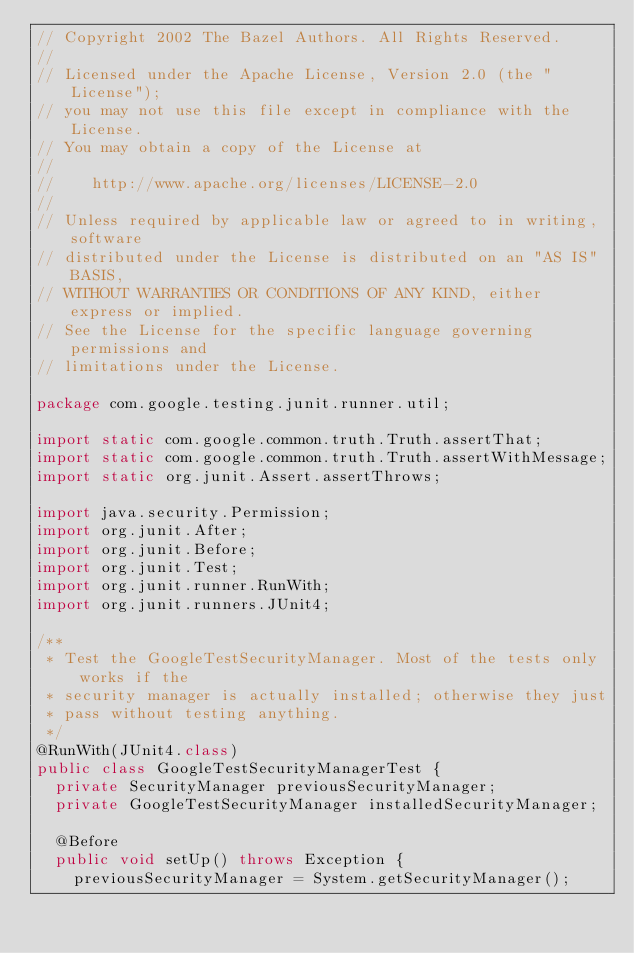Convert code to text. <code><loc_0><loc_0><loc_500><loc_500><_Java_>// Copyright 2002 The Bazel Authors. All Rights Reserved.
//
// Licensed under the Apache License, Version 2.0 (the "License");
// you may not use this file except in compliance with the License.
// You may obtain a copy of the License at
//
//    http://www.apache.org/licenses/LICENSE-2.0
//
// Unless required by applicable law or agreed to in writing, software
// distributed under the License is distributed on an "AS IS" BASIS,
// WITHOUT WARRANTIES OR CONDITIONS OF ANY KIND, either express or implied.
// See the License for the specific language governing permissions and
// limitations under the License.

package com.google.testing.junit.runner.util;

import static com.google.common.truth.Truth.assertThat;
import static com.google.common.truth.Truth.assertWithMessage;
import static org.junit.Assert.assertThrows;

import java.security.Permission;
import org.junit.After;
import org.junit.Before;
import org.junit.Test;
import org.junit.runner.RunWith;
import org.junit.runners.JUnit4;

/**
 * Test the GoogleTestSecurityManager. Most of the tests only works if the
 * security manager is actually installed; otherwise they just
 * pass without testing anything.
 */
@RunWith(JUnit4.class)
public class GoogleTestSecurityManagerTest {
  private SecurityManager previousSecurityManager;
  private GoogleTestSecurityManager installedSecurityManager;

  @Before
  public void setUp() throws Exception {
    previousSecurityManager = System.getSecurityManager();
</code> 